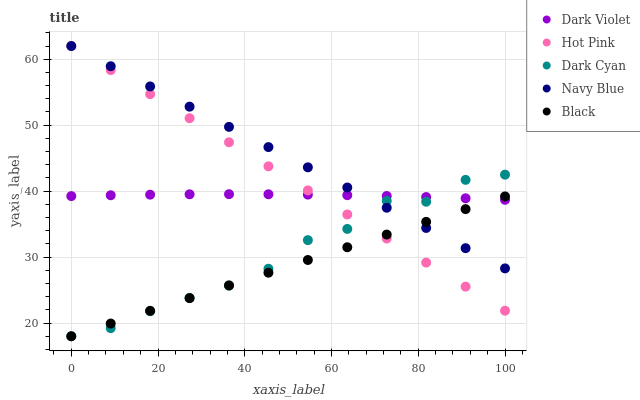Does Black have the minimum area under the curve?
Answer yes or no. Yes. Does Navy Blue have the maximum area under the curve?
Answer yes or no. Yes. Does Hot Pink have the minimum area under the curve?
Answer yes or no. No. Does Hot Pink have the maximum area under the curve?
Answer yes or no. No. Is Black the smoothest?
Answer yes or no. Yes. Is Dark Cyan the roughest?
Answer yes or no. Yes. Is Navy Blue the smoothest?
Answer yes or no. No. Is Navy Blue the roughest?
Answer yes or no. No. Does Dark Cyan have the lowest value?
Answer yes or no. Yes. Does Navy Blue have the lowest value?
Answer yes or no. No. Does Hot Pink have the highest value?
Answer yes or no. Yes. Does Black have the highest value?
Answer yes or no. No. Does Black intersect Navy Blue?
Answer yes or no. Yes. Is Black less than Navy Blue?
Answer yes or no. No. Is Black greater than Navy Blue?
Answer yes or no. No. 